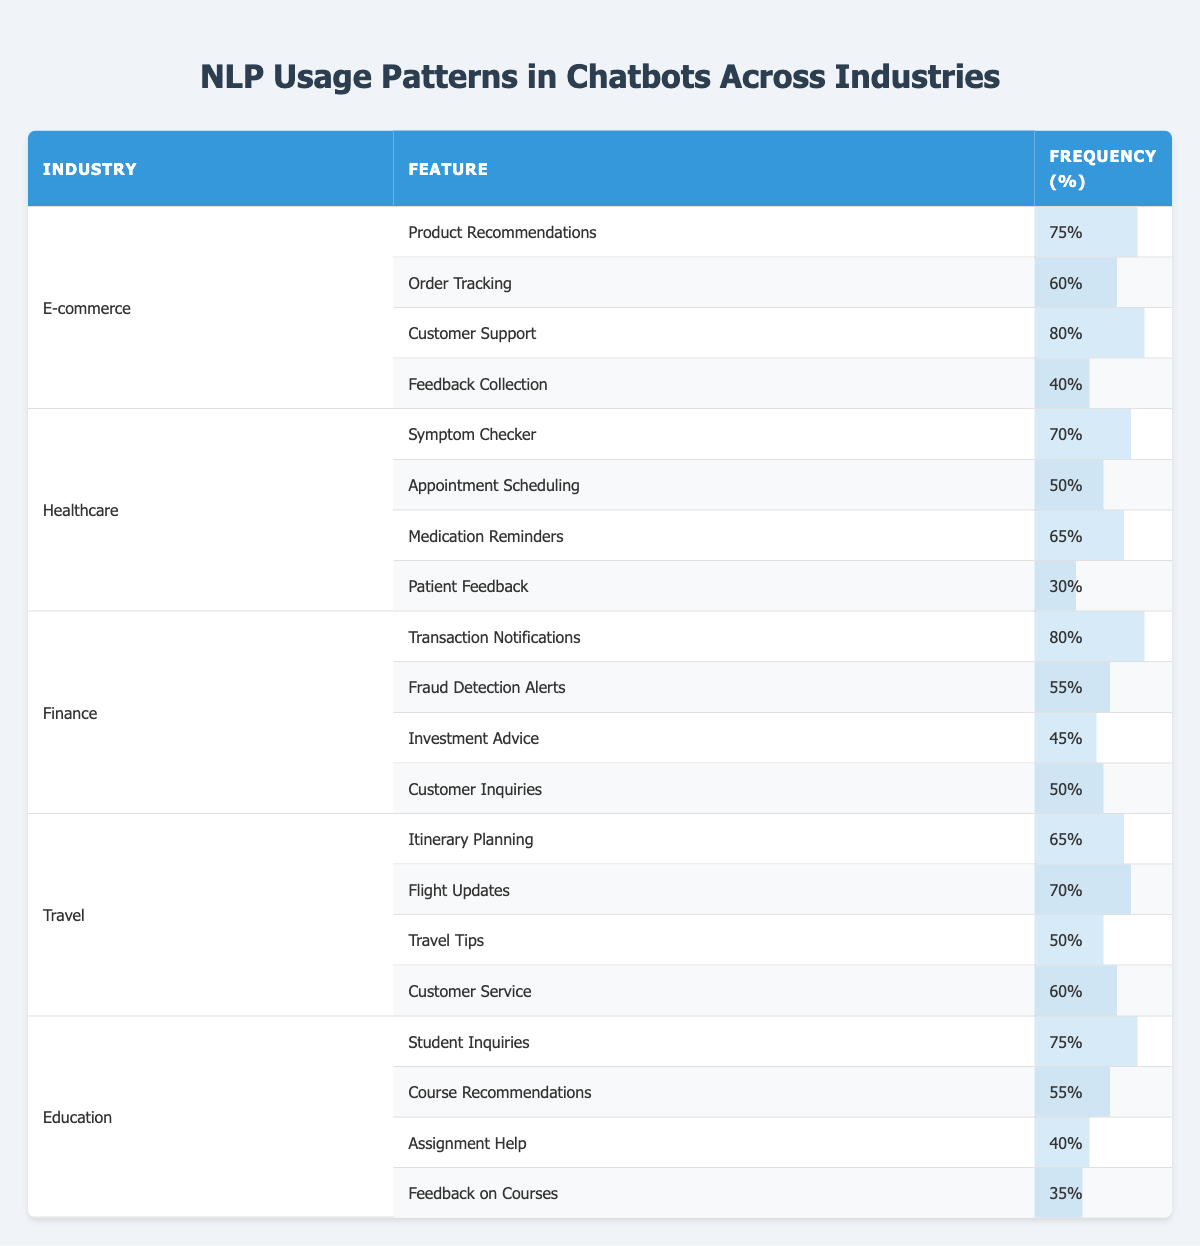What is the most frequently used feature in E-commerce chatbots? In the E-commerce section, the feature with the highest frequency is "Customer Support" with a frequency of 80%.
Answer: 80% Which industry has the lowest frequency for any feature? In the Healthcare sector, the feature "Patient Feedback" has the lowest frequency, which is 30%.
Answer: 30% What is the average frequency of features used in the Finance industry? The sum of frequencies in the Finance sector is (80 + 55 + 45 + 50) = 230, and there are 4 features, so the average frequency is 230/4 = 57.5.
Answer: 57.5 Is "Order Tracking" used more frequently than "Customer Inquiries"? "Order Tracking" frequency is 60% and "Customer Inquiries" frequency is 50%. Since 60% is greater than 50%, the answer is yes.
Answer: Yes Which industry has the highest total frequency for its features? Sum the frequencies for each industry: E-commerce (75+60+80+40=255), Healthcare (70+50+65+30=215), Finance (80+55+45+50=230), Travel (65+70+50+60=245), Education (75+55+40+35=205). E-commerce has the highest total of 255.
Answer: E-commerce What percentage of features in the Education industry have a frequency of 50% or less? In the Education industry, there are 4 features: only "Assignment Help" (40%) and "Feedback on Courses" (35%) have frequencies of 50% or less. Thus, 2 out of 4 features qualify, resulting in 2/4 = 0.5 or 50%.
Answer: 50% Which feature is most commonly used across all industries? Looking at the frequencies, "Customer Support" in E-commerce is at 80% and "Transaction Notifications" in Finance is also at 80%. Both are the highest but in different industries, hence there's no single feature that tops across all.
Answer: None How does the frequency of "Product Recommendations" in E-commerce compare to "Symptom Checker" in Healthcare? "Product Recommendations" is at 75% while "Symptom Checker" is at 70%. Comparing these values, 75% is greater than 70%.
Answer: 75% is greater What is the overall trend in feature usage frequencies across the industries? By examining the frequencies, it can be observed that features in E-commerce are frequently used compared to other industries, like Healthcare and Education which have more low-frequency features, indicating a general trend of higher usage in E-commerce.
Answer: Higher usage in E-commerce What is the difference in frequency between the highest and lowest feature in the Travel industry? The highest frequency in the Travel industry is for "Flight Updates" at 70%, and the lowest is "Travel Tips" at 50%. The difference is 70 - 50 = 20.
Answer: 20 